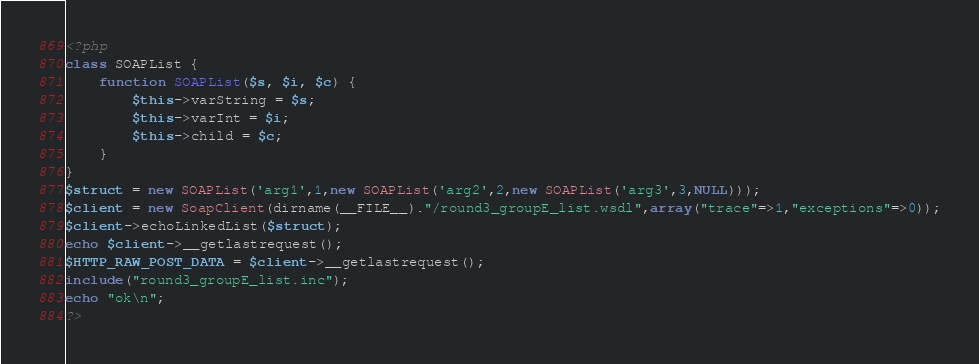<code> <loc_0><loc_0><loc_500><loc_500><_PHP_><?php
class SOAPList {
    function SOAPList($s, $i, $c) {
        $this->varString = $s;
        $this->varInt = $i;
        $this->child = $c;
    }
}
$struct = new SOAPList('arg1',1,new SOAPList('arg2',2,new SOAPList('arg3',3,NULL)));
$client = new SoapClient(dirname(__FILE__)."/round3_groupE_list.wsdl",array("trace"=>1,"exceptions"=>0));
$client->echoLinkedList($struct);
echo $client->__getlastrequest();
$HTTP_RAW_POST_DATA = $client->__getlastrequest();
include("round3_groupE_list.inc");
echo "ok\n";
?>
</code> 